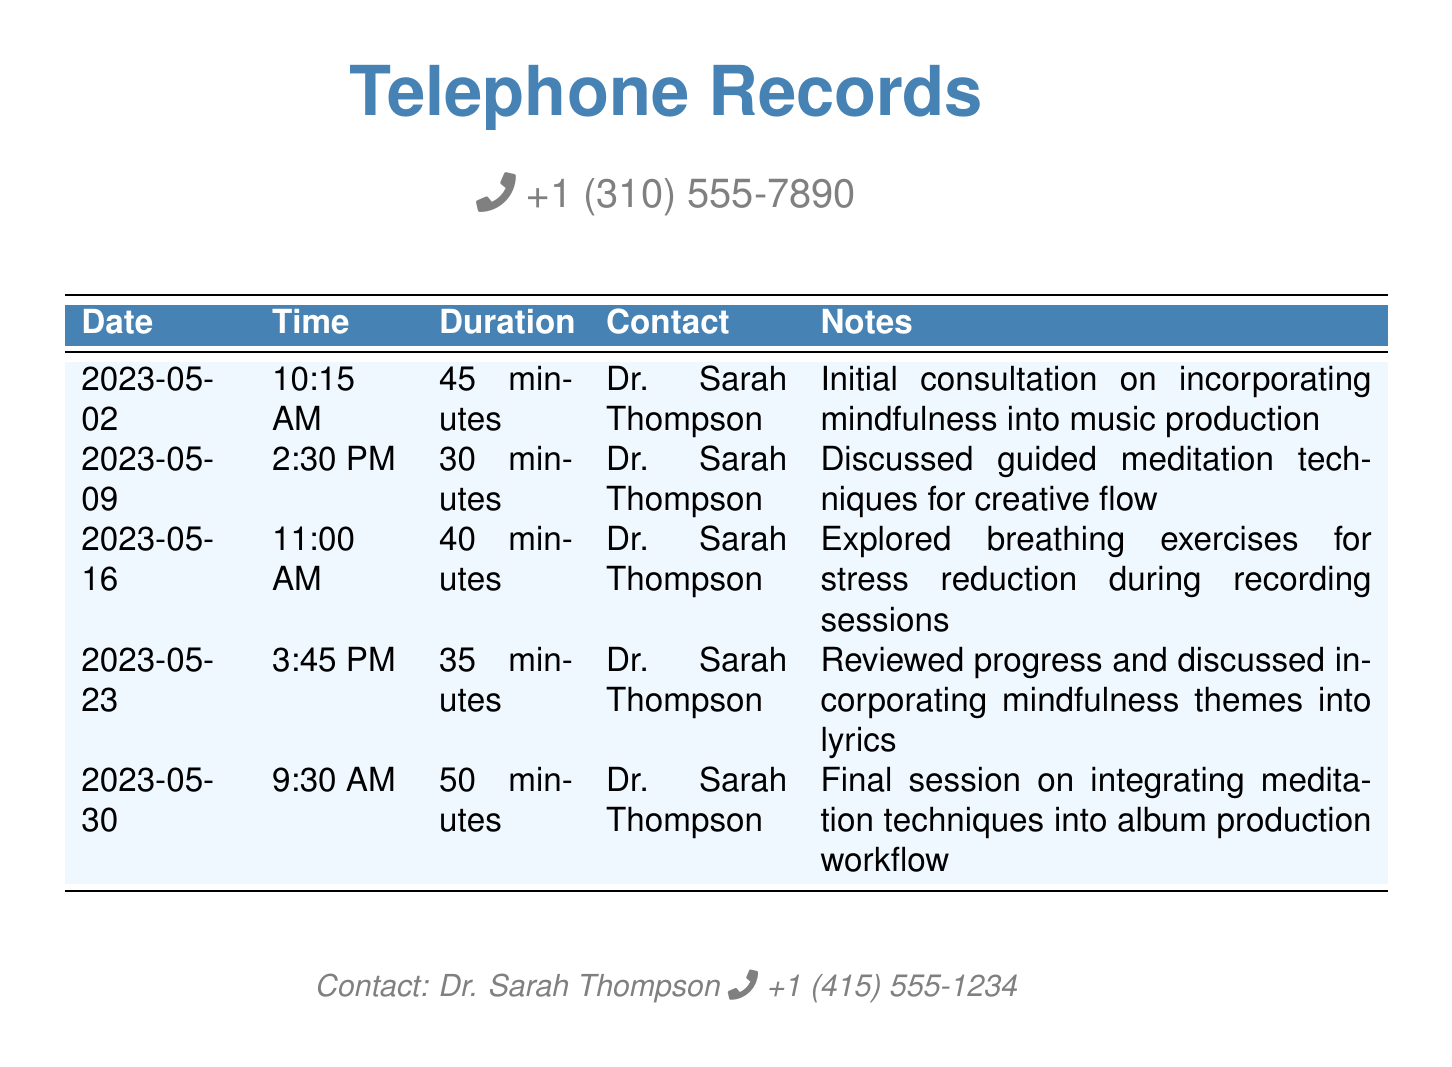What is the contact's name? The contact listed in the document is Dr. Sarah Thompson, who is the mindfulness coach.
Answer: Dr. Sarah Thompson How long was the first consultation? The duration of the first consultation on May 2, 2023, is specifically stated in the document as 45 minutes.
Answer: 45 minutes What date was the last session? The document indicates that the final session took place on May 30, 2023.
Answer: 2023-05-30 How many sessions were conducted with Dr. Sarah Thompson? The document lists five separate sessions, indicating the total conducted with Dr. Sarah Thompson.
Answer: Five What technique was discussed on May 9, 2023? The specific technique discussed on that date involved guided meditation for enhancing creative flow in music production.
Answer: Guided meditation techniques What were the breathing exercises for? The breathing exercises discussed on May 16, 2023, were for stress reduction during recording sessions.
Answer: Stress reduction What is the duration of the session on May 30, 2023? The duration for the last session noted on that date was 50 minutes.
Answer: 50 minutes What theme was incorporated into the lyrics? The session on May 23, 2023, involved incorporating mindfulness themes into the lyrics of the music.
Answer: Mindfulness themes 